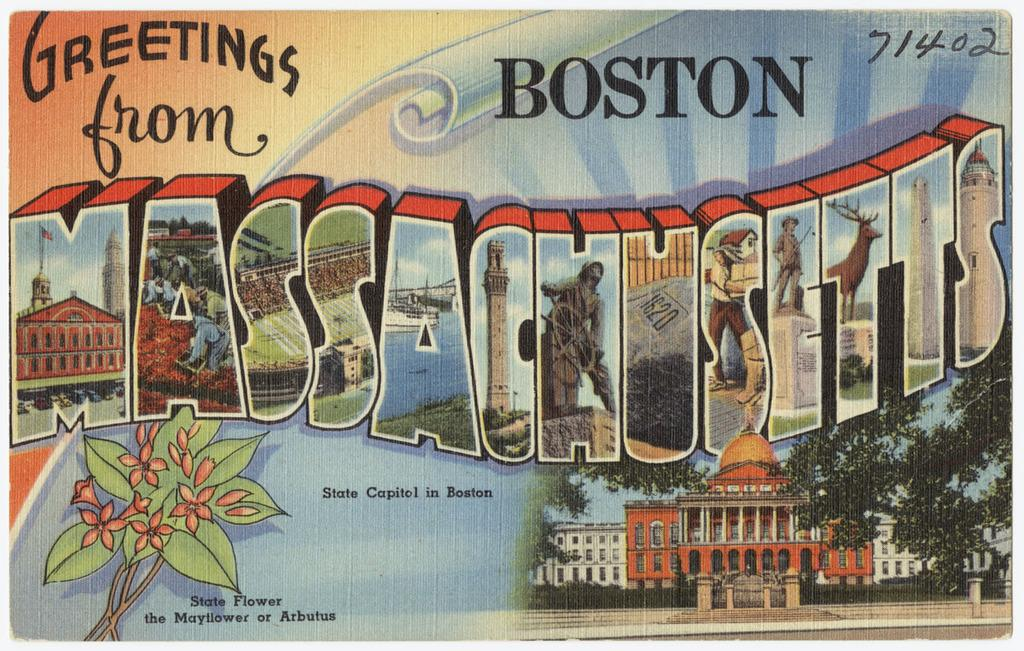<image>
Give a short and clear explanation of the subsequent image. A postcard that reads Greetings from Boston on it. 